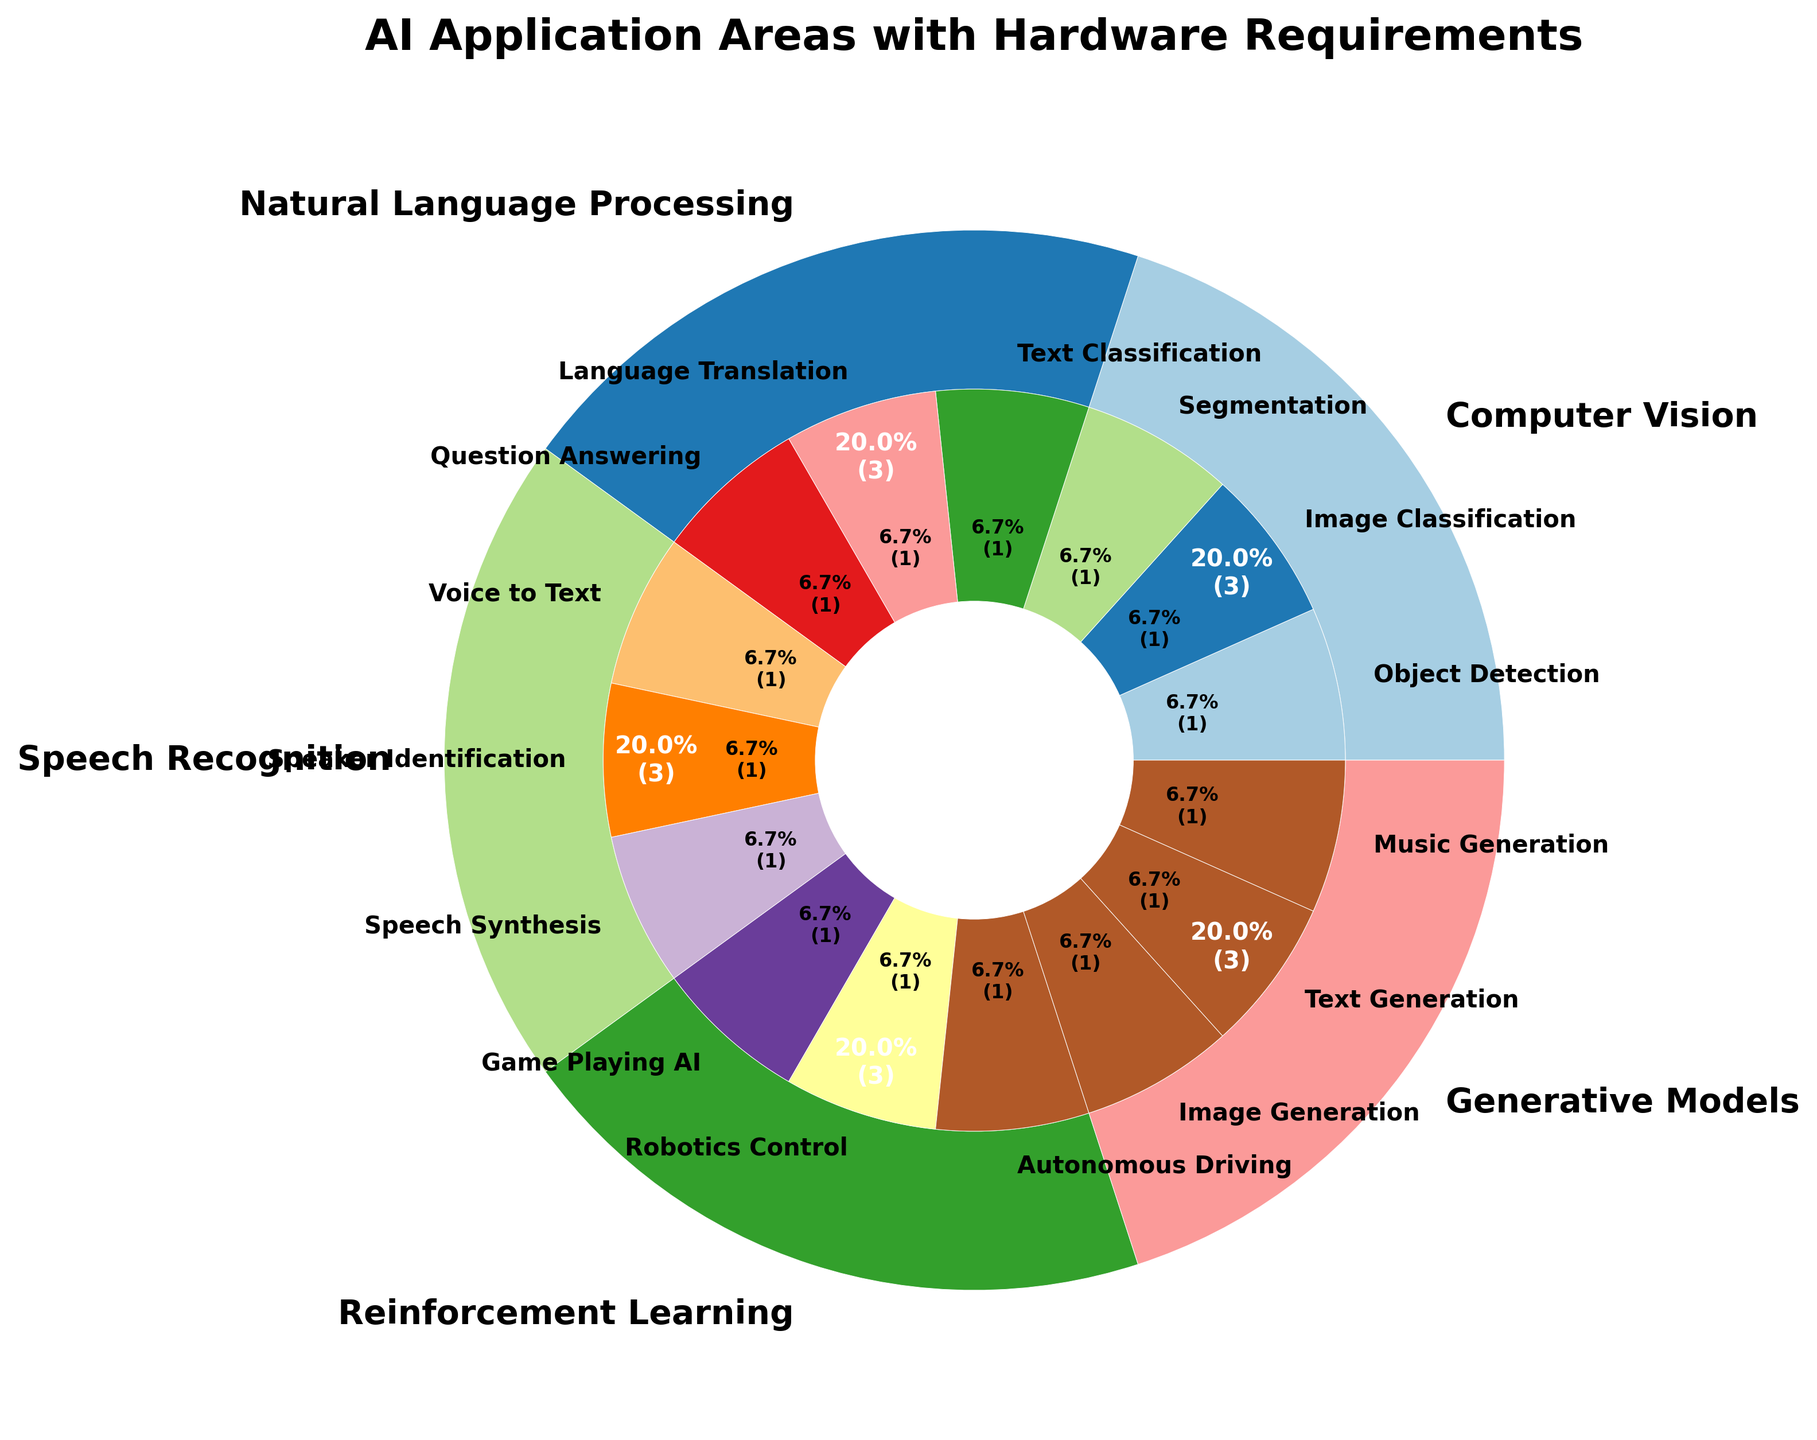Which AI application area requires the most compute power? We look for the section of the outer ring representing the AI application area with the highest value for compute power. Reinforcement Learning has subareas with the highest compute power (up to 55 TFLOPS).
Answer: Reinforcement Learning How many subareas are in the Natural Language Processing area? Natural Language Processing area is part of the nested pie chart, and by counting its inner sections, we find 3 subareas: Text Classification, Language Translation, and Question Answering.
Answer: 3 Which AI subarea within Computer Vision requires the highest bandwidth? Within the Computer Vision section of the nested pie chart, we identify the subareas and compare their bandwidth requirements. Segmentation has the highest with 350 GB/s.
Answer: Segmentation Compare the memory requirements between Speech Recognition subareas and Generative Models subareas. Which area generally requires more memory? Speech Recognition subareas are "Voice to Text" (7GB), "Speaker Identification" (5GB), "Speech Synthesis" (9GB). Generative Models subareas are "Image Generation" (14GB), "Text Generation" (11GB), and "Music Generation" (13GB). Generally, Generative Models require more memory since their minimum is 11GB, higher than any Speech Recognition subarea.
Answer: Generative Models Which subarea has the highest memory requirement and how much is it? We identify the subarea in the nested pie chart across all AI application areas with the highest memory requirement. Reinforcement Learning's Autonomous Driving has the highest with 28GB.
Answer: Autonomous Driving, 28GB What is the total bandwidth required for all subareas of Generative Models? We sum up the bandwidth values for all subareas within Generative Models: Image Generation (450 GB/s), Text Generation (360 GB/s), and Music Generation (400 GB/s). Total bandwidth is 450 + 360 + 400 = 1210 GB/s.
Answer: 1210 GB/s Which AI application area has the most subareas, and how many does it have? By counting the number of subareas in each AI application area in the pie chart, we see that both Natural Language Processing and Reinforcement Learning have the most with 3 subareas each.
Answer: Natural Language Processing and Reinforcement Learning, 3 each 